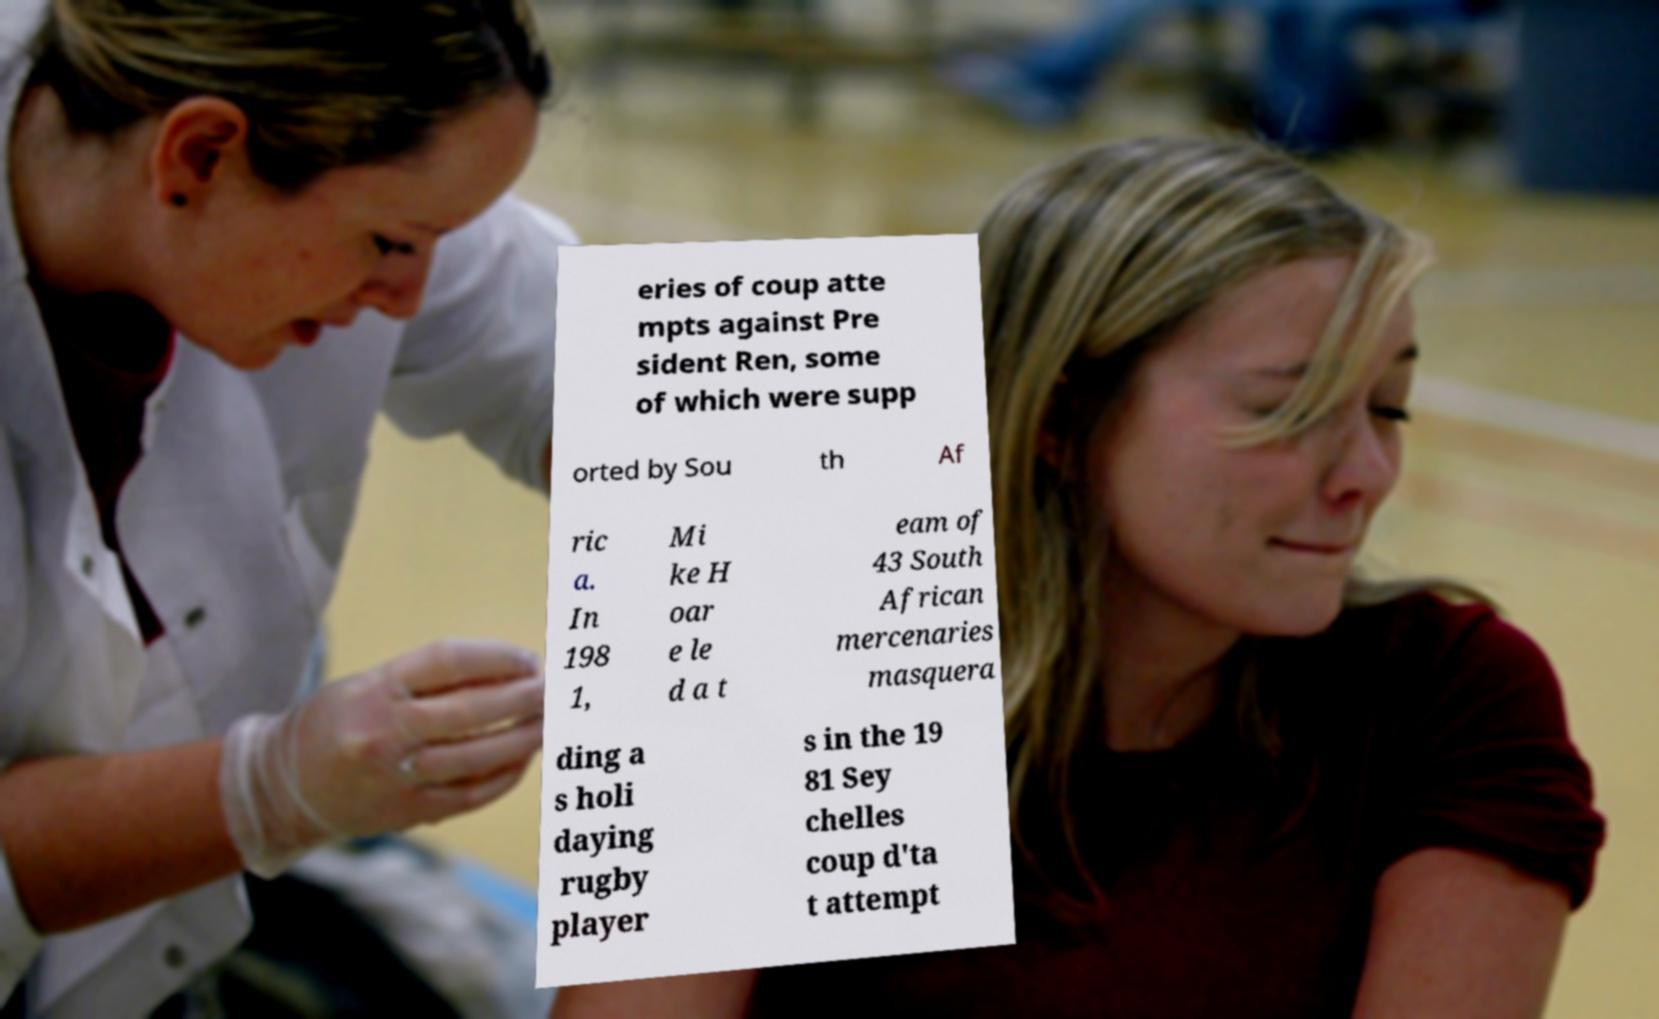Could you assist in decoding the text presented in this image and type it out clearly? eries of coup atte mpts against Pre sident Ren, some of which were supp orted by Sou th Af ric a. In 198 1, Mi ke H oar e le d a t eam of 43 South African mercenaries masquera ding a s holi daying rugby player s in the 19 81 Sey chelles coup d'ta t attempt 